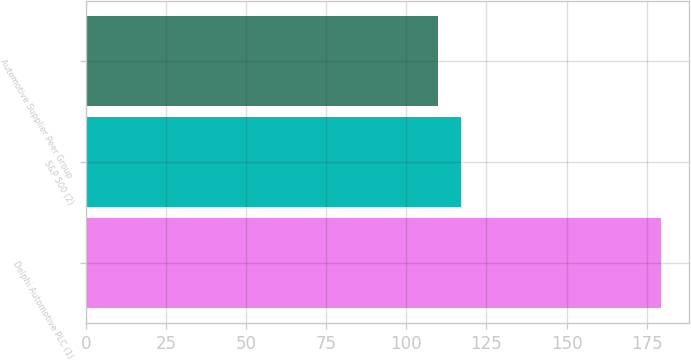Convert chart. <chart><loc_0><loc_0><loc_500><loc_500><bar_chart><fcel>Delphi Automotive PLC (1)<fcel>S&P 500 (2)<fcel>Automotive Supplier Peer Group<nl><fcel>179.33<fcel>116.93<fcel>109.96<nl></chart> 